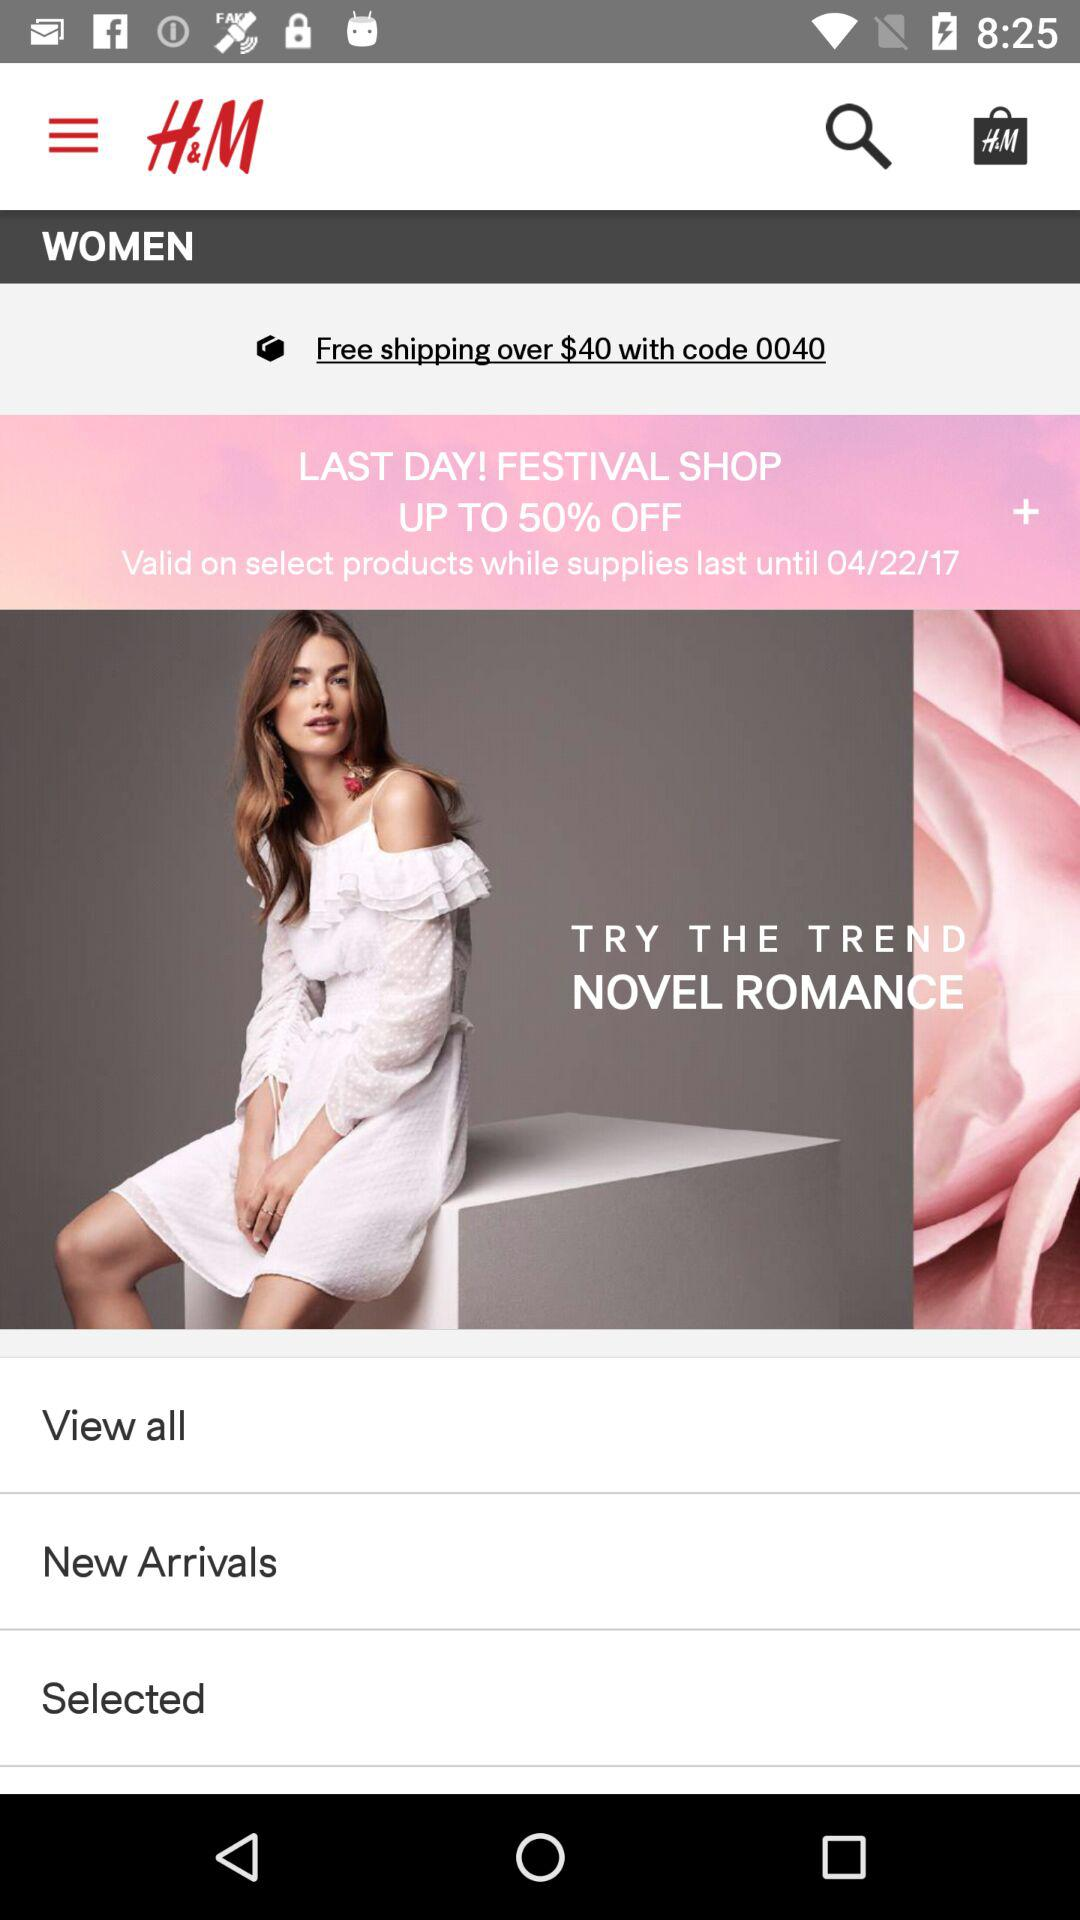What percentage of discount is mentioned for the festival shop? The mentioned discount is up to 50% off. 